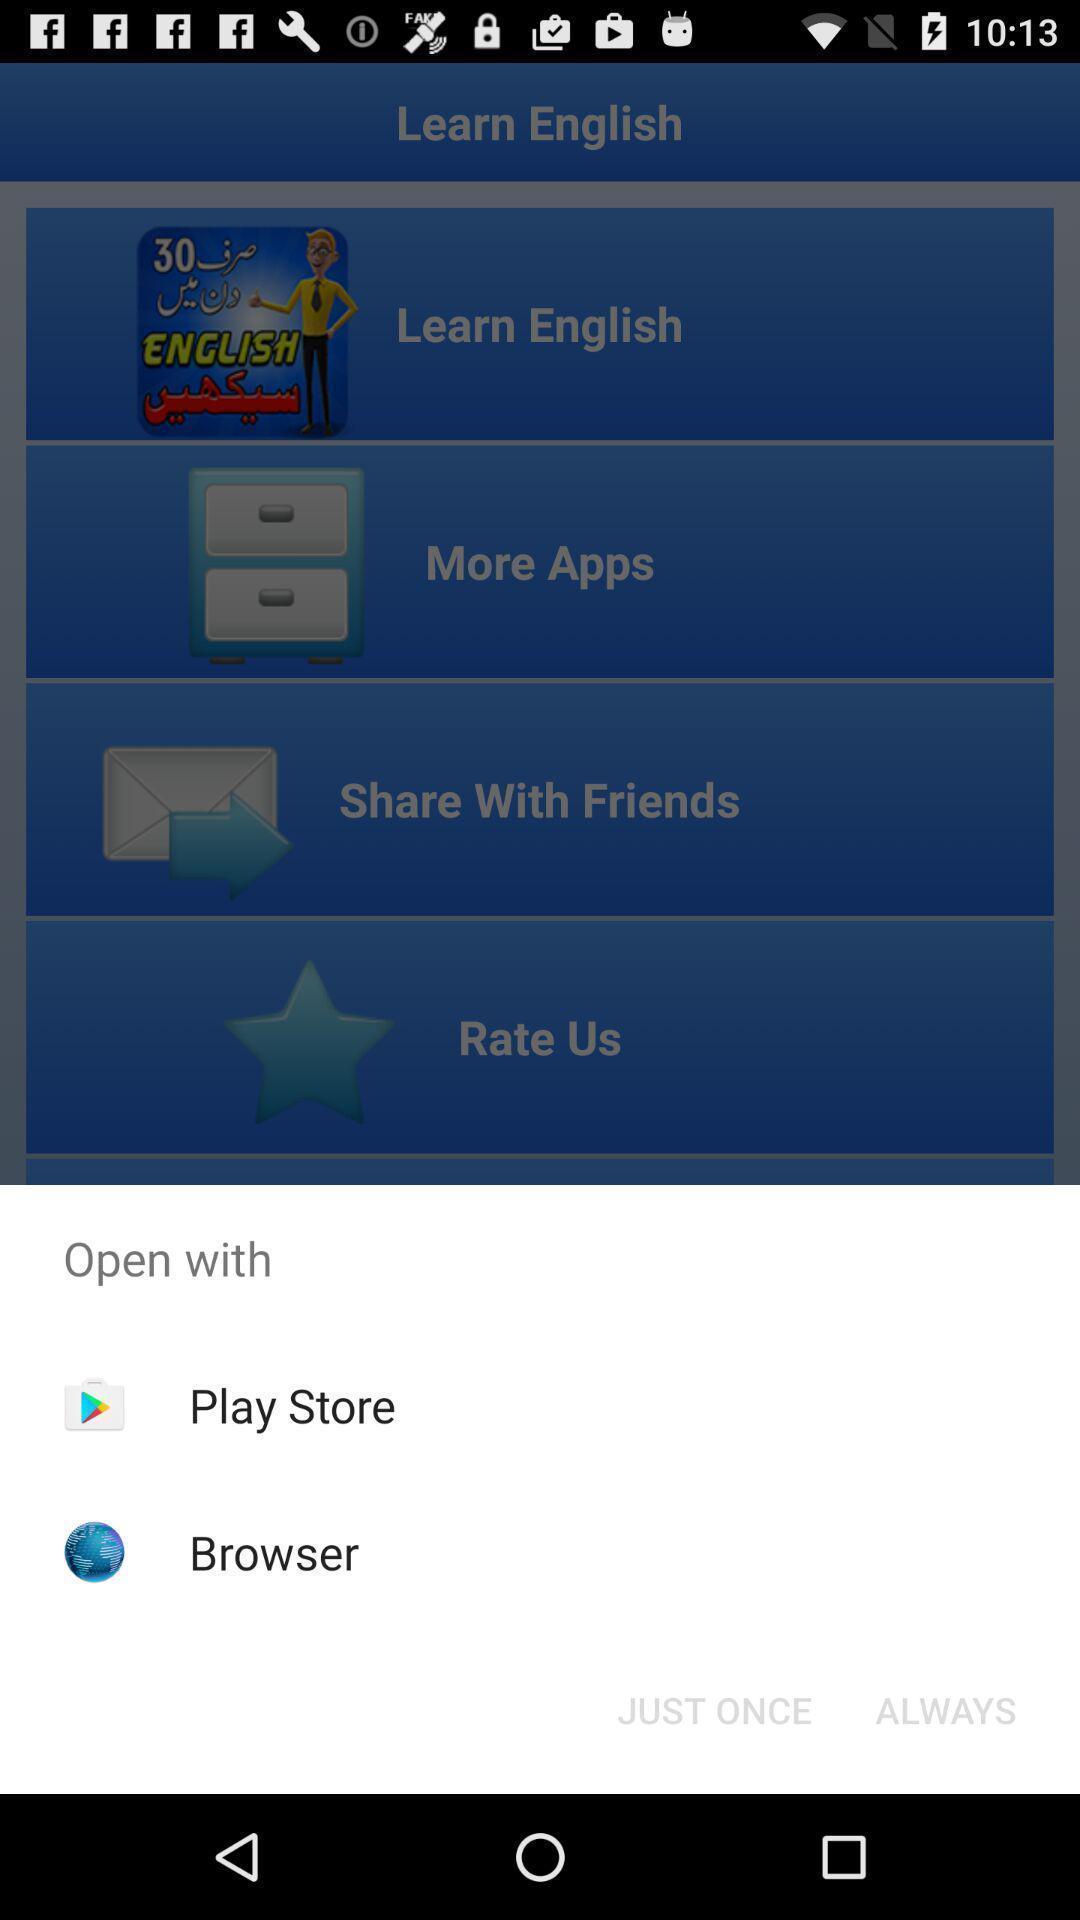Describe the visual elements of this screenshot. Widget displaying two browsing options. 